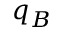Convert formula to latex. <formula><loc_0><loc_0><loc_500><loc_500>q _ { B }</formula> 